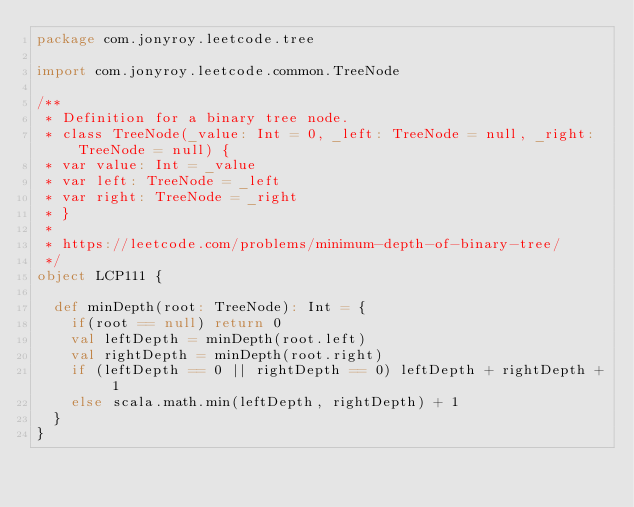Convert code to text. <code><loc_0><loc_0><loc_500><loc_500><_Scala_>package com.jonyroy.leetcode.tree

import com.jonyroy.leetcode.common.TreeNode

/**
 * Definition for a binary tree node.
 * class TreeNode(_value: Int = 0, _left: TreeNode = null, _right: TreeNode = null) {
 * var value: Int = _value
 * var left: TreeNode = _left
 * var right: TreeNode = _right
 * }
 *
 * https://leetcode.com/problems/minimum-depth-of-binary-tree/
 */
object LCP111 {

  def minDepth(root: TreeNode): Int = {
    if(root == null) return 0
    val leftDepth = minDepth(root.left)
    val rightDepth = minDepth(root.right)
    if (leftDepth == 0 || rightDepth == 0) leftDepth + rightDepth + 1
    else scala.math.min(leftDepth, rightDepth) + 1
  }
}
</code> 